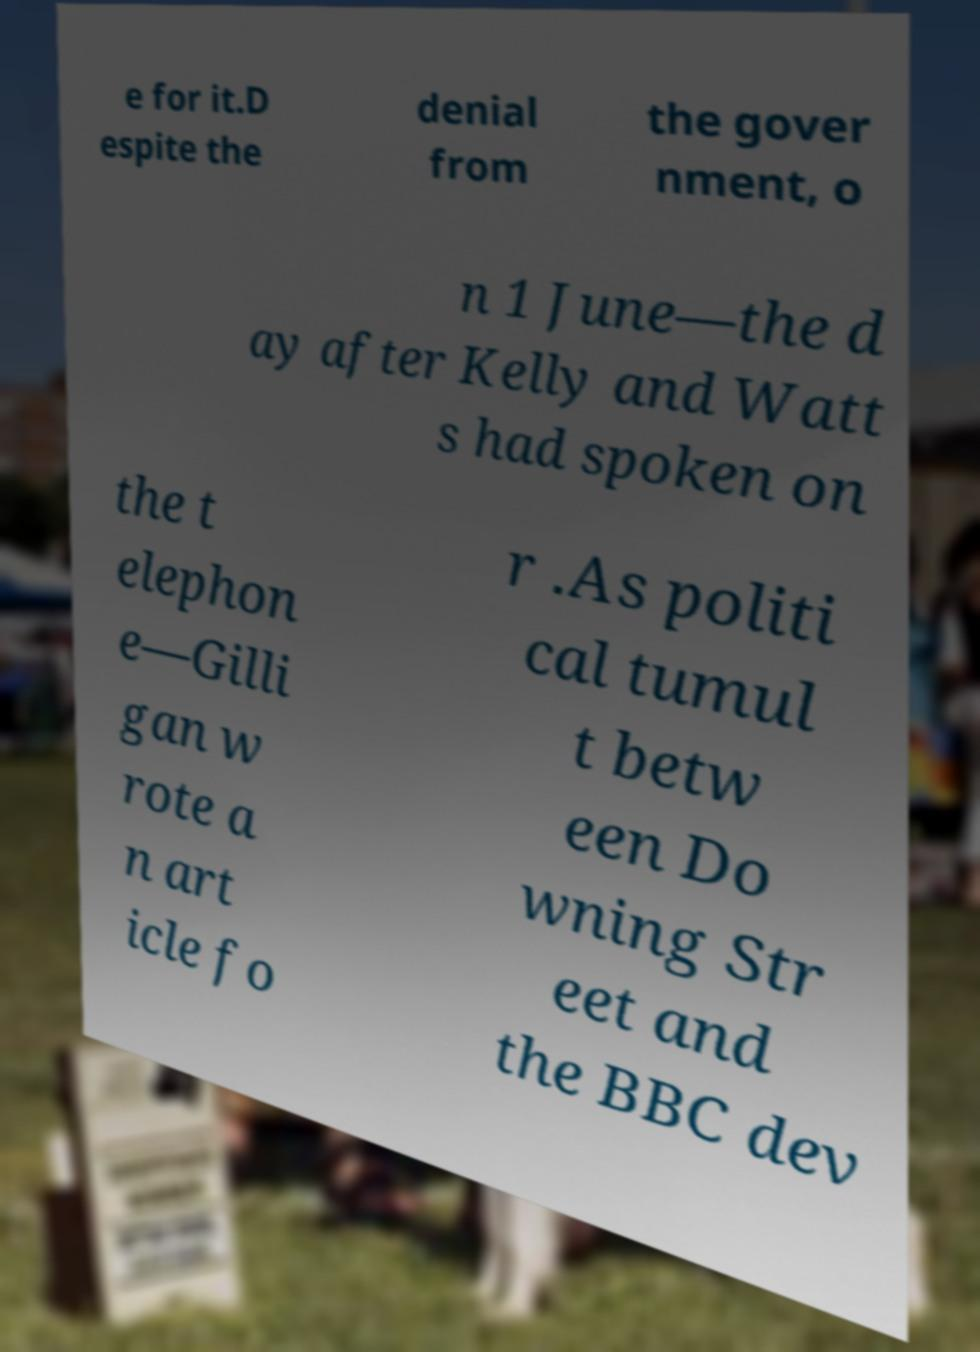What messages or text are displayed in this image? I need them in a readable, typed format. e for it.D espite the denial from the gover nment, o n 1 June—the d ay after Kelly and Watt s had spoken on the t elephon e—Gilli gan w rote a n art icle fo r .As politi cal tumul t betw een Do wning Str eet and the BBC dev 